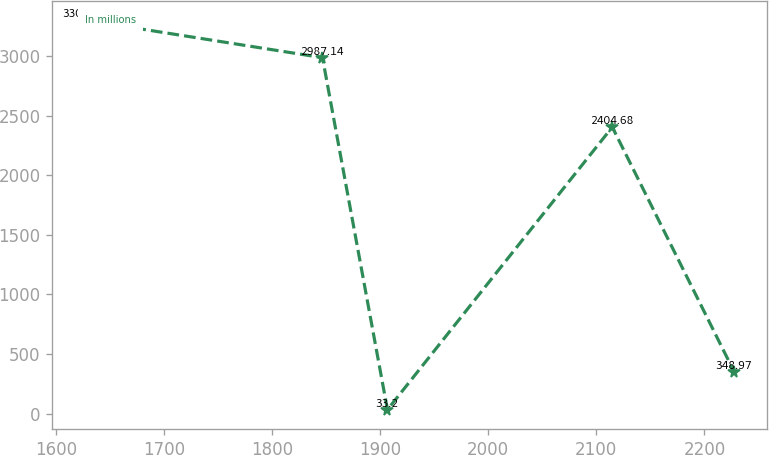Convert chart to OTSL. <chart><loc_0><loc_0><loc_500><loc_500><line_chart><ecel><fcel>In millions<nl><fcel>1626.62<fcel>3302.91<nl><fcel>1846.67<fcel>2987.14<nl><fcel>1906.76<fcel>33.2<nl><fcel>2114.73<fcel>2404.68<nl><fcel>2227.56<fcel>348.97<nl></chart> 